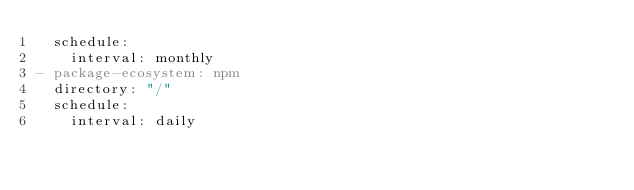<code> <loc_0><loc_0><loc_500><loc_500><_YAML_>  schedule:
    interval: monthly
- package-ecosystem: npm
  directory: "/"
  schedule:
    interval: daily</code> 